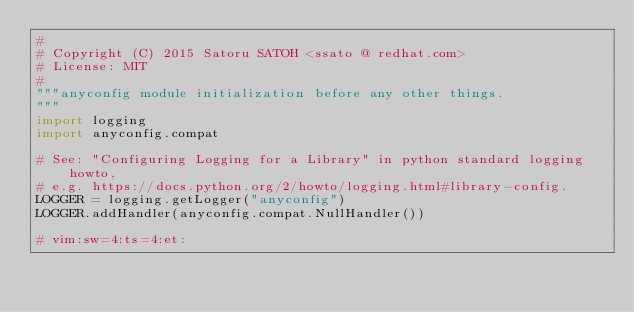<code> <loc_0><loc_0><loc_500><loc_500><_Python_>#
# Copyright (C) 2015 Satoru SATOH <ssato @ redhat.com>
# License: MIT
#
"""anyconfig module initialization before any other things.
"""
import logging
import anyconfig.compat

# See: "Configuring Logging for a Library" in python standard logging howto,
# e.g. https://docs.python.org/2/howto/logging.html#library-config.
LOGGER = logging.getLogger("anyconfig")
LOGGER.addHandler(anyconfig.compat.NullHandler())

# vim:sw=4:ts=4:et:
</code> 